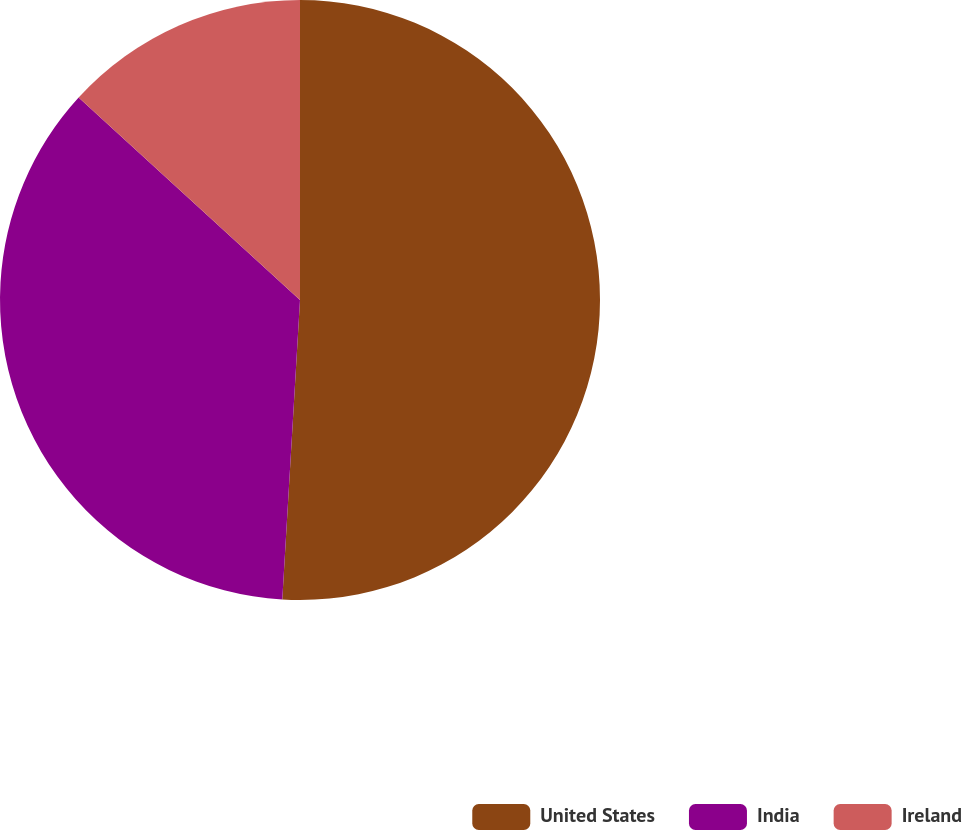<chart> <loc_0><loc_0><loc_500><loc_500><pie_chart><fcel>United States<fcel>India<fcel>Ireland<nl><fcel>50.94%<fcel>35.85%<fcel>13.21%<nl></chart> 